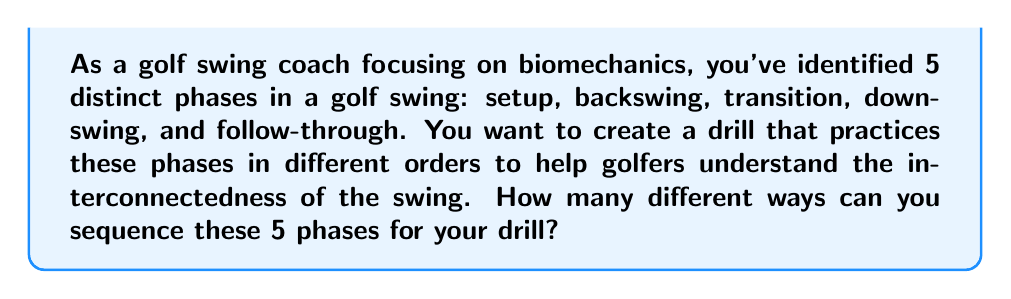Provide a solution to this math problem. To solve this problem, we need to use the concept of permutations. A permutation is an arrangement of objects where order matters. In this case, we have 5 distinct phases, and we want to arrange all 5 of them in different orders.

The formula for permutations of n distinct objects is:

$$P(n) = n!$$

Where $n!$ (n factorial) is the product of all positive integers less than or equal to n.

In our case, $n = 5$ (setup, backswing, transition, downswing, and follow-through).

So, we calculate:

$$\begin{align*}
P(5) &= 5! \\
&= 5 \times 4 \times 3 \times 2 \times 1 \\
&= 120
\end{align*}$$

This means there are 120 different ways to sequence the 5 phases of a golf swing.

To break it down:
1. We have 5 choices for the first phase
2. After choosing the first, we have 4 choices for the second phase
3. Then 3 choices for the third phase
4. 2 choices for the fourth phase
5. Only 1 choice left for the last phase

Multiplying these together: $5 \times 4 \times 3 \times 2 \times 1 = 120$

This calculation gives us all possible sequences, allowing the coach to create a comprehensive set of drills that cover every possible order of the swing phases.
Answer: $120$ different sequences 